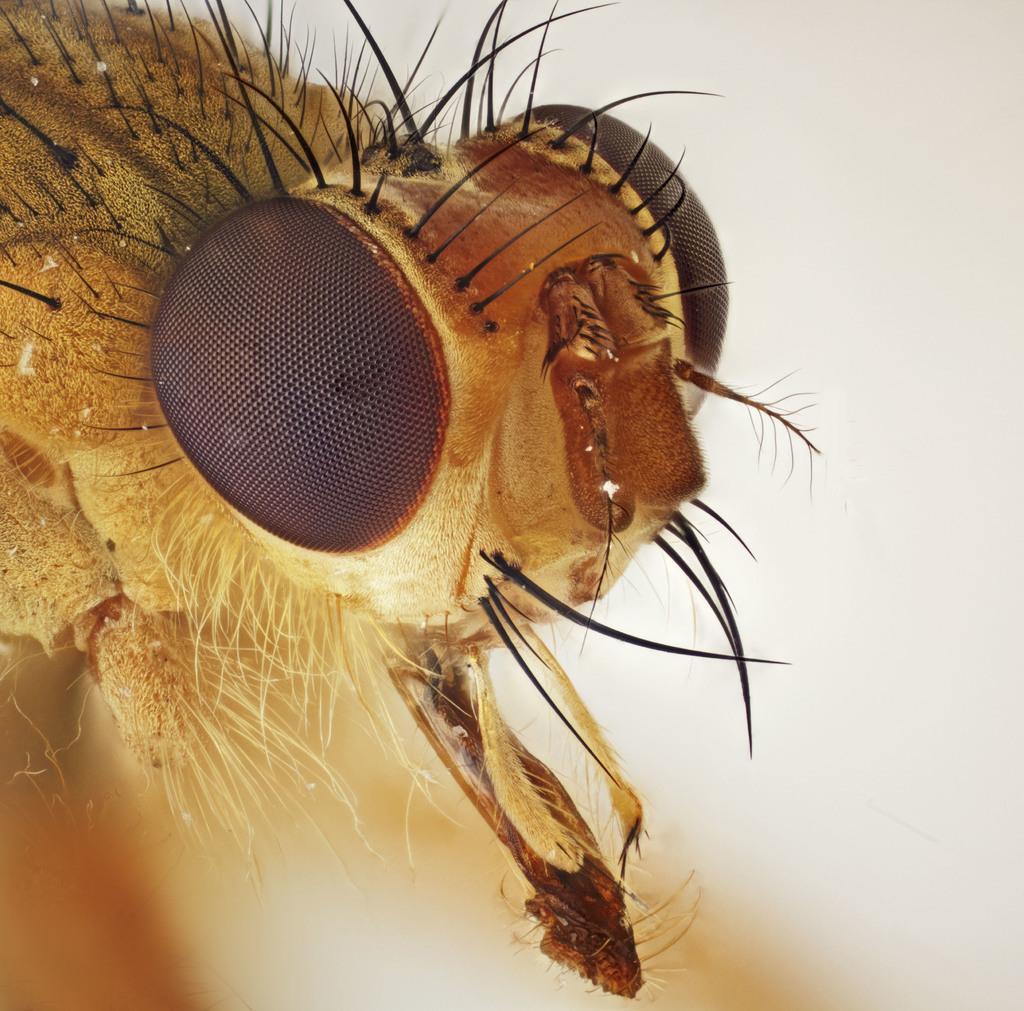Could you give a brief overview of what you see in this image? In this image we can see a insect with hairs. The background of the image is white in color. 